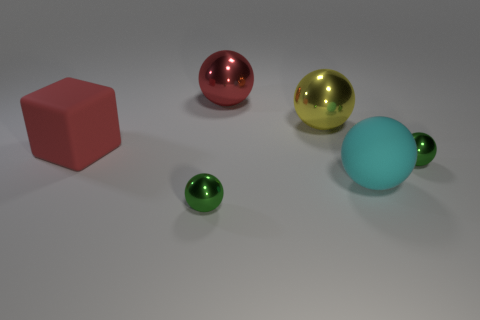Subtract all big yellow spheres. How many spheres are left? 4 Subtract all cyan spheres. How many spheres are left? 4 Subtract all balls. How many objects are left? 1 Add 2 large yellow shiny balls. How many objects exist? 8 Subtract all green cubes. How many cyan balls are left? 1 Subtract all red spheres. Subtract all tiny cyan matte balls. How many objects are left? 5 Add 1 small things. How many small things are left? 3 Add 6 small metallic balls. How many small metallic balls exist? 8 Subtract 0 brown blocks. How many objects are left? 6 Subtract 1 spheres. How many spheres are left? 4 